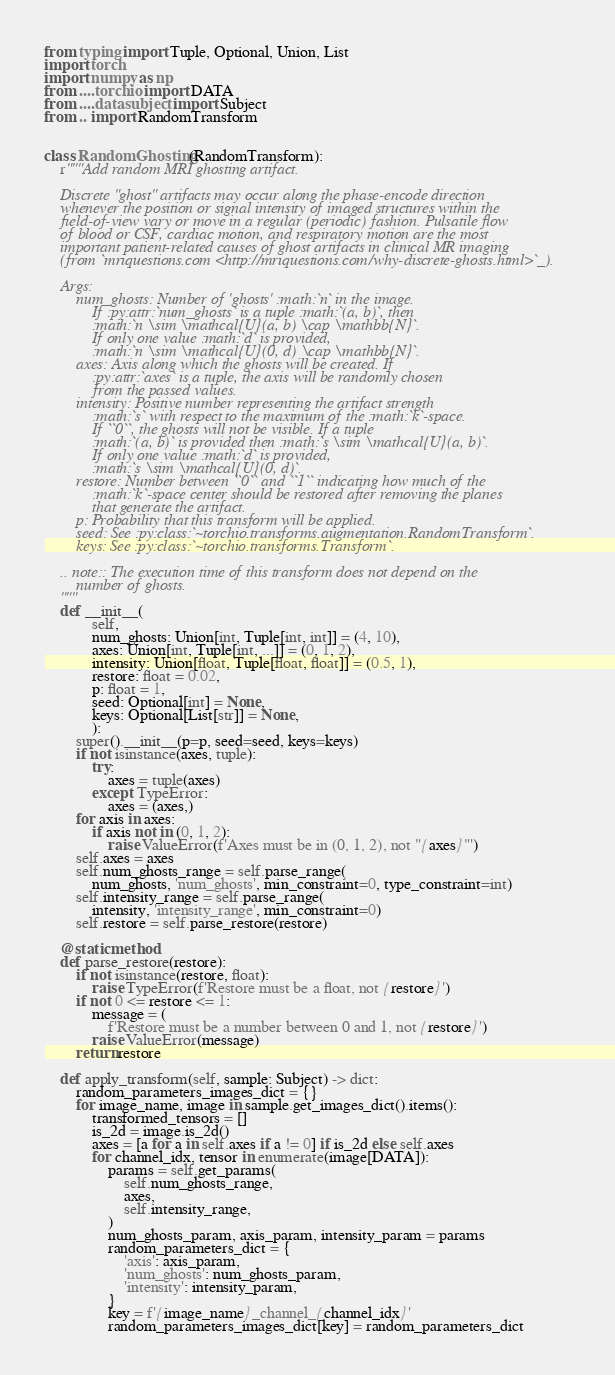Convert code to text. <code><loc_0><loc_0><loc_500><loc_500><_Python_>from typing import Tuple, Optional, Union, List
import torch
import numpy as np
from ....torchio import DATA
from ....data.subject import Subject
from .. import RandomTransform


class RandomGhosting(RandomTransform):
    r"""Add random MRI ghosting artifact.

    Discrete "ghost" artifacts may occur along the phase-encode direction
    whenever the position or signal intensity of imaged structures within the
    field-of-view vary or move in a regular (periodic) fashion. Pulsatile flow
    of blood or CSF, cardiac motion, and respiratory motion are the most
    important patient-related causes of ghost artifacts in clinical MR imaging
    (from `mriquestions.com <http://mriquestions.com/why-discrete-ghosts.html>`_).

    Args:
        num_ghosts: Number of 'ghosts' :math:`n` in the image.
            If :py:attr:`num_ghosts` is a tuple :math:`(a, b)`, then
            :math:`n \sim \mathcal{U}(a, b) \cap \mathbb{N}`.
            If only one value :math:`d` is provided,
            :math:`n \sim \mathcal{U}(0, d) \cap \mathbb{N}`.
        axes: Axis along which the ghosts will be created. If
            :py:attr:`axes` is a tuple, the axis will be randomly chosen
            from the passed values.
        intensity: Positive number representing the artifact strength
            :math:`s` with respect to the maximum of the :math:`k`-space.
            If ``0``, the ghosts will not be visible. If a tuple
            :math:`(a, b)` is provided then :math:`s \sim \mathcal{U}(a, b)`.
            If only one value :math:`d` is provided,
            :math:`s \sim \mathcal{U}(0, d)`.
        restore: Number between ``0`` and ``1`` indicating how much of the
            :math:`k`-space center should be restored after removing the planes
            that generate the artifact.
        p: Probability that this transform will be applied.
        seed: See :py:class:`~torchio.transforms.augmentation.RandomTransform`.
        keys: See :py:class:`~torchio.transforms.Transform`.

    .. note:: The execution time of this transform does not depend on the
        number of ghosts.
    """
    def __init__(
            self,
            num_ghosts: Union[int, Tuple[int, int]] = (4, 10),
            axes: Union[int, Tuple[int, ...]] = (0, 1, 2),
            intensity: Union[float, Tuple[float, float]] = (0.5, 1),
            restore: float = 0.02,
            p: float = 1,
            seed: Optional[int] = None,
            keys: Optional[List[str]] = None,
            ):
        super().__init__(p=p, seed=seed, keys=keys)
        if not isinstance(axes, tuple):
            try:
                axes = tuple(axes)
            except TypeError:
                axes = (axes,)
        for axis in axes:
            if axis not in (0, 1, 2):
                raise ValueError(f'Axes must be in (0, 1, 2), not "{axes}"')
        self.axes = axes
        self.num_ghosts_range = self.parse_range(
            num_ghosts, 'num_ghosts', min_constraint=0, type_constraint=int)
        self.intensity_range = self.parse_range(
            intensity, 'intensity_range', min_constraint=0)
        self.restore = self.parse_restore(restore)

    @staticmethod
    def parse_restore(restore):
        if not isinstance(restore, float):
            raise TypeError(f'Restore must be a float, not {restore}')
        if not 0 <= restore <= 1:
            message = (
                f'Restore must be a number between 0 and 1, not {restore}')
            raise ValueError(message)
        return restore

    def apply_transform(self, sample: Subject) -> dict:
        random_parameters_images_dict = {}
        for image_name, image in sample.get_images_dict().items():
            transformed_tensors = []
            is_2d = image.is_2d()
            axes = [a for a in self.axes if a != 0] if is_2d else self.axes
            for channel_idx, tensor in enumerate(image[DATA]):
                params = self.get_params(
                    self.num_ghosts_range,
                    axes,
                    self.intensity_range,
                )
                num_ghosts_param, axis_param, intensity_param = params
                random_parameters_dict = {
                    'axis': axis_param,
                    'num_ghosts': num_ghosts_param,
                    'intensity': intensity_param,
                }
                key = f'{image_name}_channel_{channel_idx}'
                random_parameters_images_dict[key] = random_parameters_dict</code> 